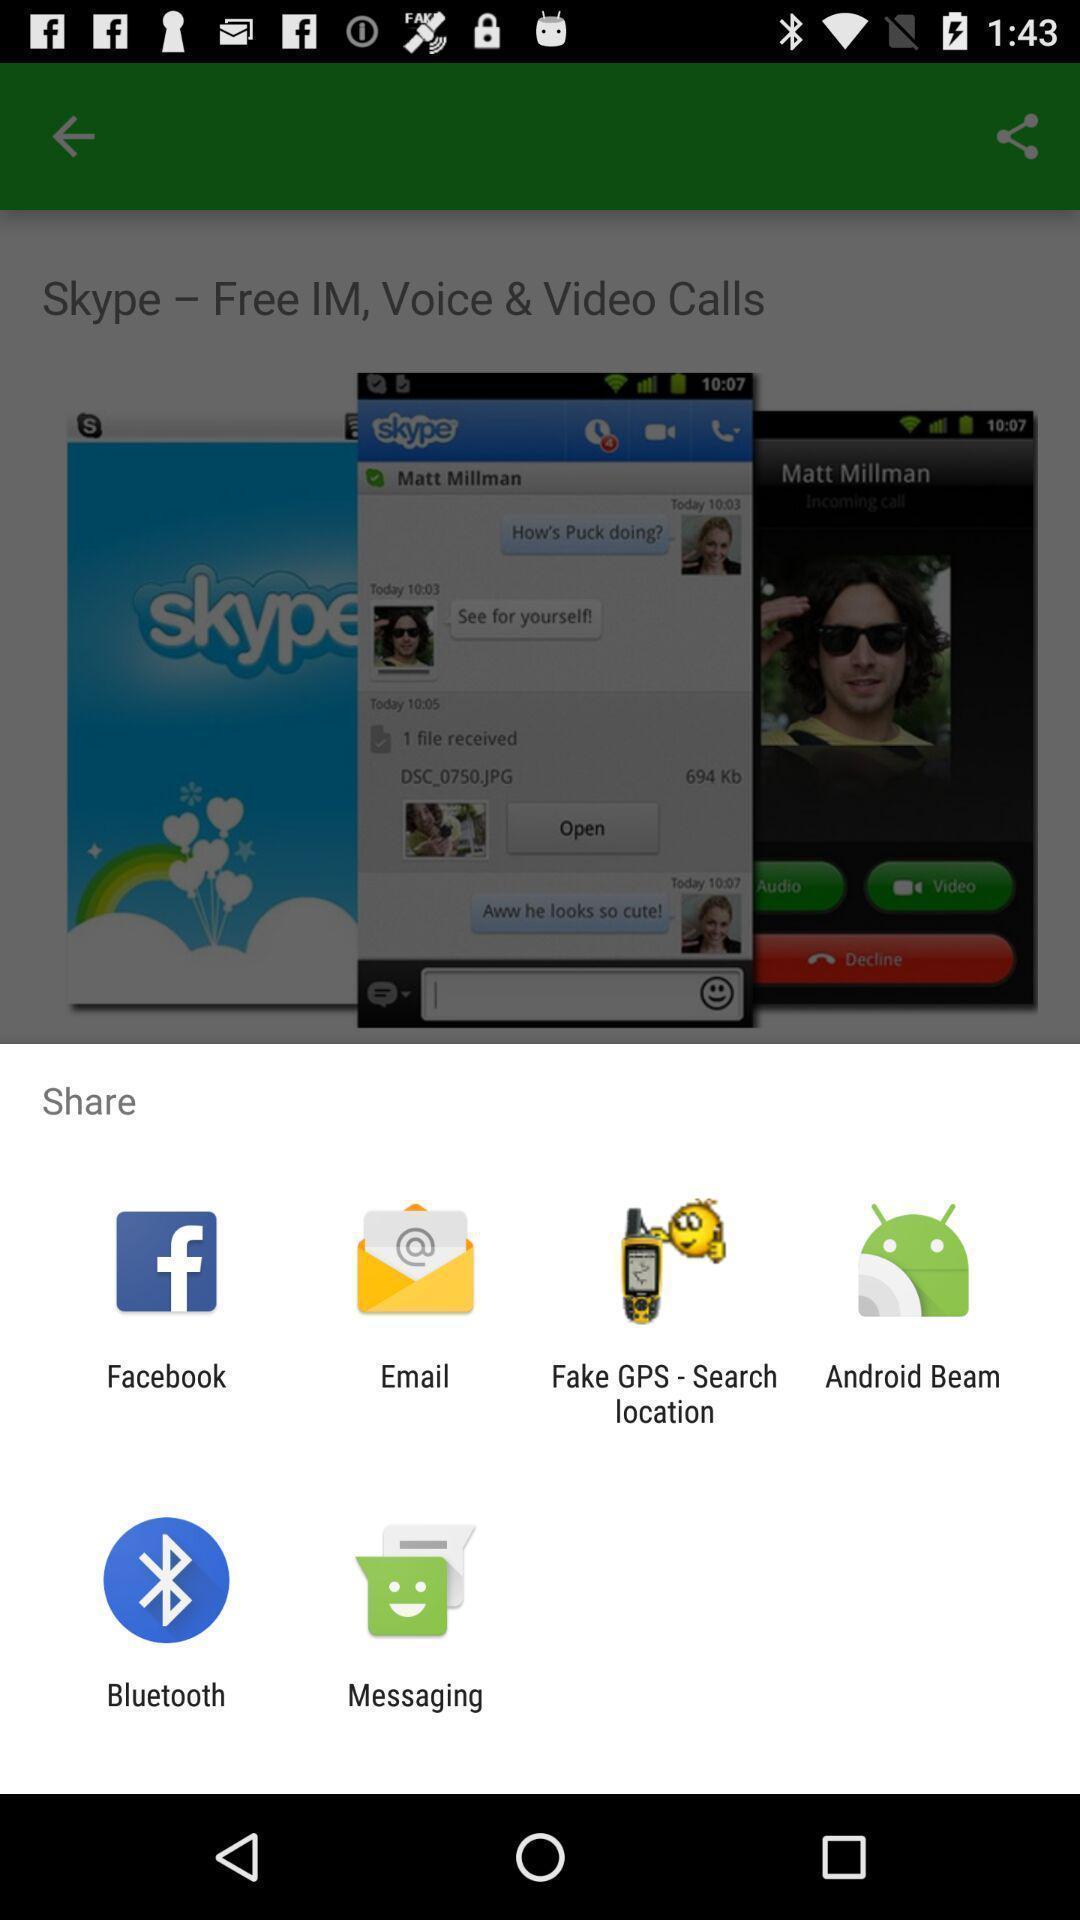Tell me about the visual elements in this screen capture. Sharing options in the app. 